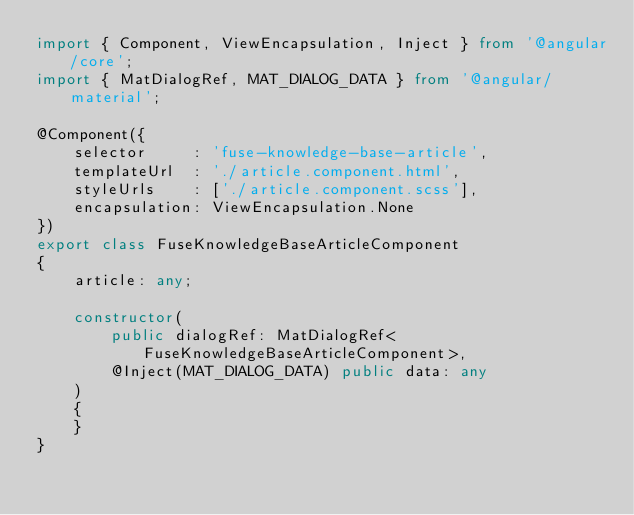Convert code to text. <code><loc_0><loc_0><loc_500><loc_500><_TypeScript_>import { Component, ViewEncapsulation, Inject } from '@angular/core';
import { MatDialogRef, MAT_DIALOG_DATA } from '@angular/material';

@Component({
    selector     : 'fuse-knowledge-base-article',
    templateUrl  : './article.component.html',
    styleUrls    : ['./article.component.scss'],
    encapsulation: ViewEncapsulation.None
})
export class FuseKnowledgeBaseArticleComponent
{
    article: any;

    constructor(
        public dialogRef: MatDialogRef<FuseKnowledgeBaseArticleComponent>,
        @Inject(MAT_DIALOG_DATA) public data: any
    )
    {
    }
}
</code> 